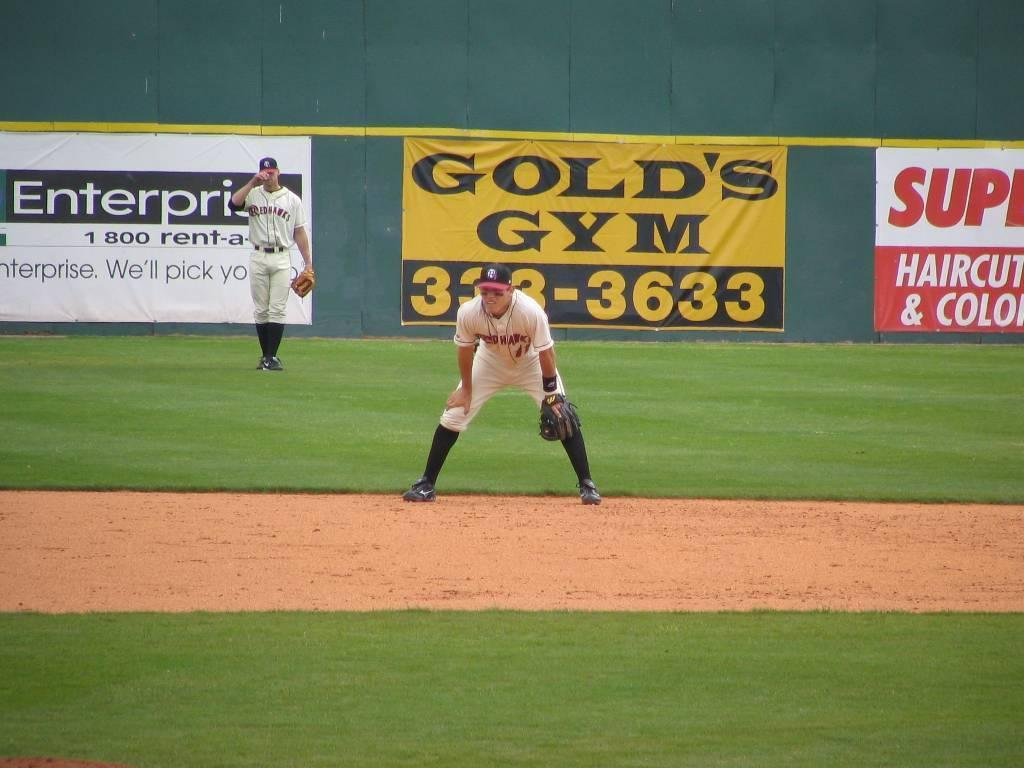<image>
Present a compact description of the photo's key features. An ad for Golds Gym is behind two players on the field 